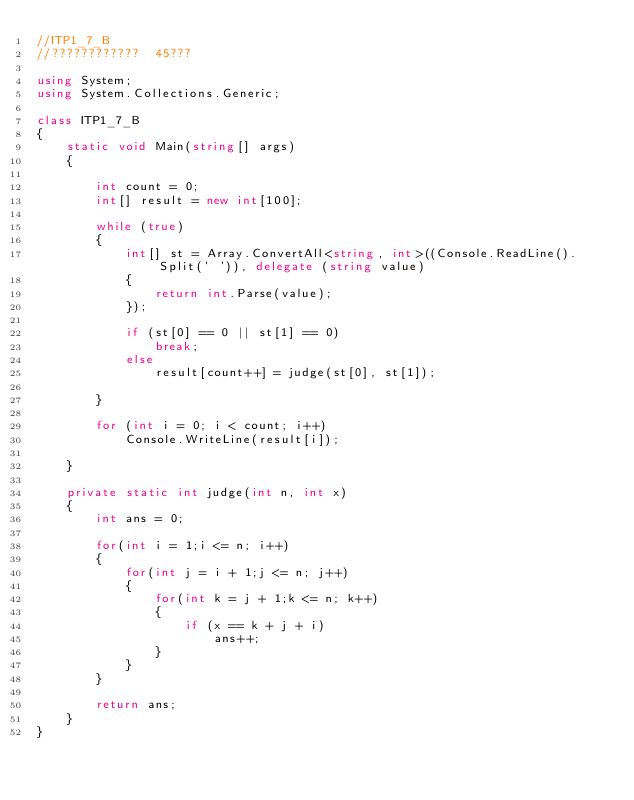<code> <loc_0><loc_0><loc_500><loc_500><_C#_>//ITP1_7_B
//????????????  45???

using System;
using System.Collections.Generic;

class ITP1_7_B
{
    static void Main(string[] args)
    {

        int count = 0;
        int[] result = new int[100];

        while (true)
        {
            int[] st = Array.ConvertAll<string, int>((Console.ReadLine().Split(' ')), delegate (string value)
            {
                return int.Parse(value);
            });

            if (st[0] == 0 || st[1] == 0)
                break;
            else
                result[count++] = judge(st[0], st[1]);

        }

        for (int i = 0; i < count; i++)
            Console.WriteLine(result[i]);

    }

    private static int judge(int n, int x)
    {
        int ans = 0;

        for(int i = 1;i <= n; i++)
        {
            for(int j = i + 1;j <= n; j++)
            {
                for(int k = j + 1;k <= n; k++)
                {
                    if (x == k + j + i)
                        ans++;
                }
            }    
        }

        return ans;
    }
}</code> 